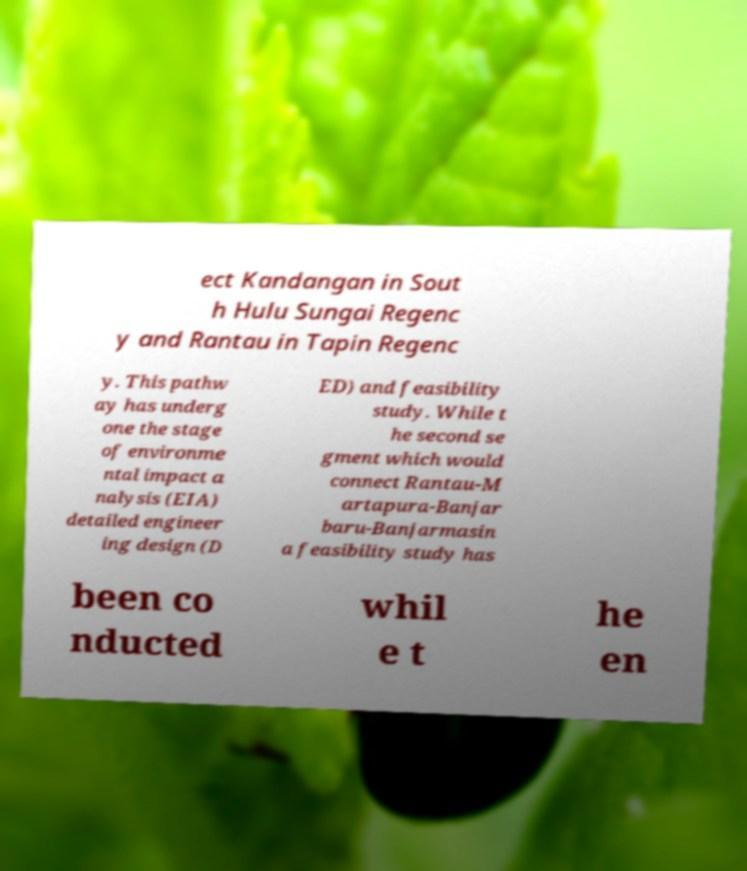Could you extract and type out the text from this image? ect Kandangan in Sout h Hulu Sungai Regenc y and Rantau in Tapin Regenc y. This pathw ay has underg one the stage of environme ntal impact a nalysis (EIA) detailed engineer ing design (D ED) and feasibility study. While t he second se gment which would connect Rantau-M artapura-Banjar baru-Banjarmasin a feasibility study has been co nducted whil e t he en 